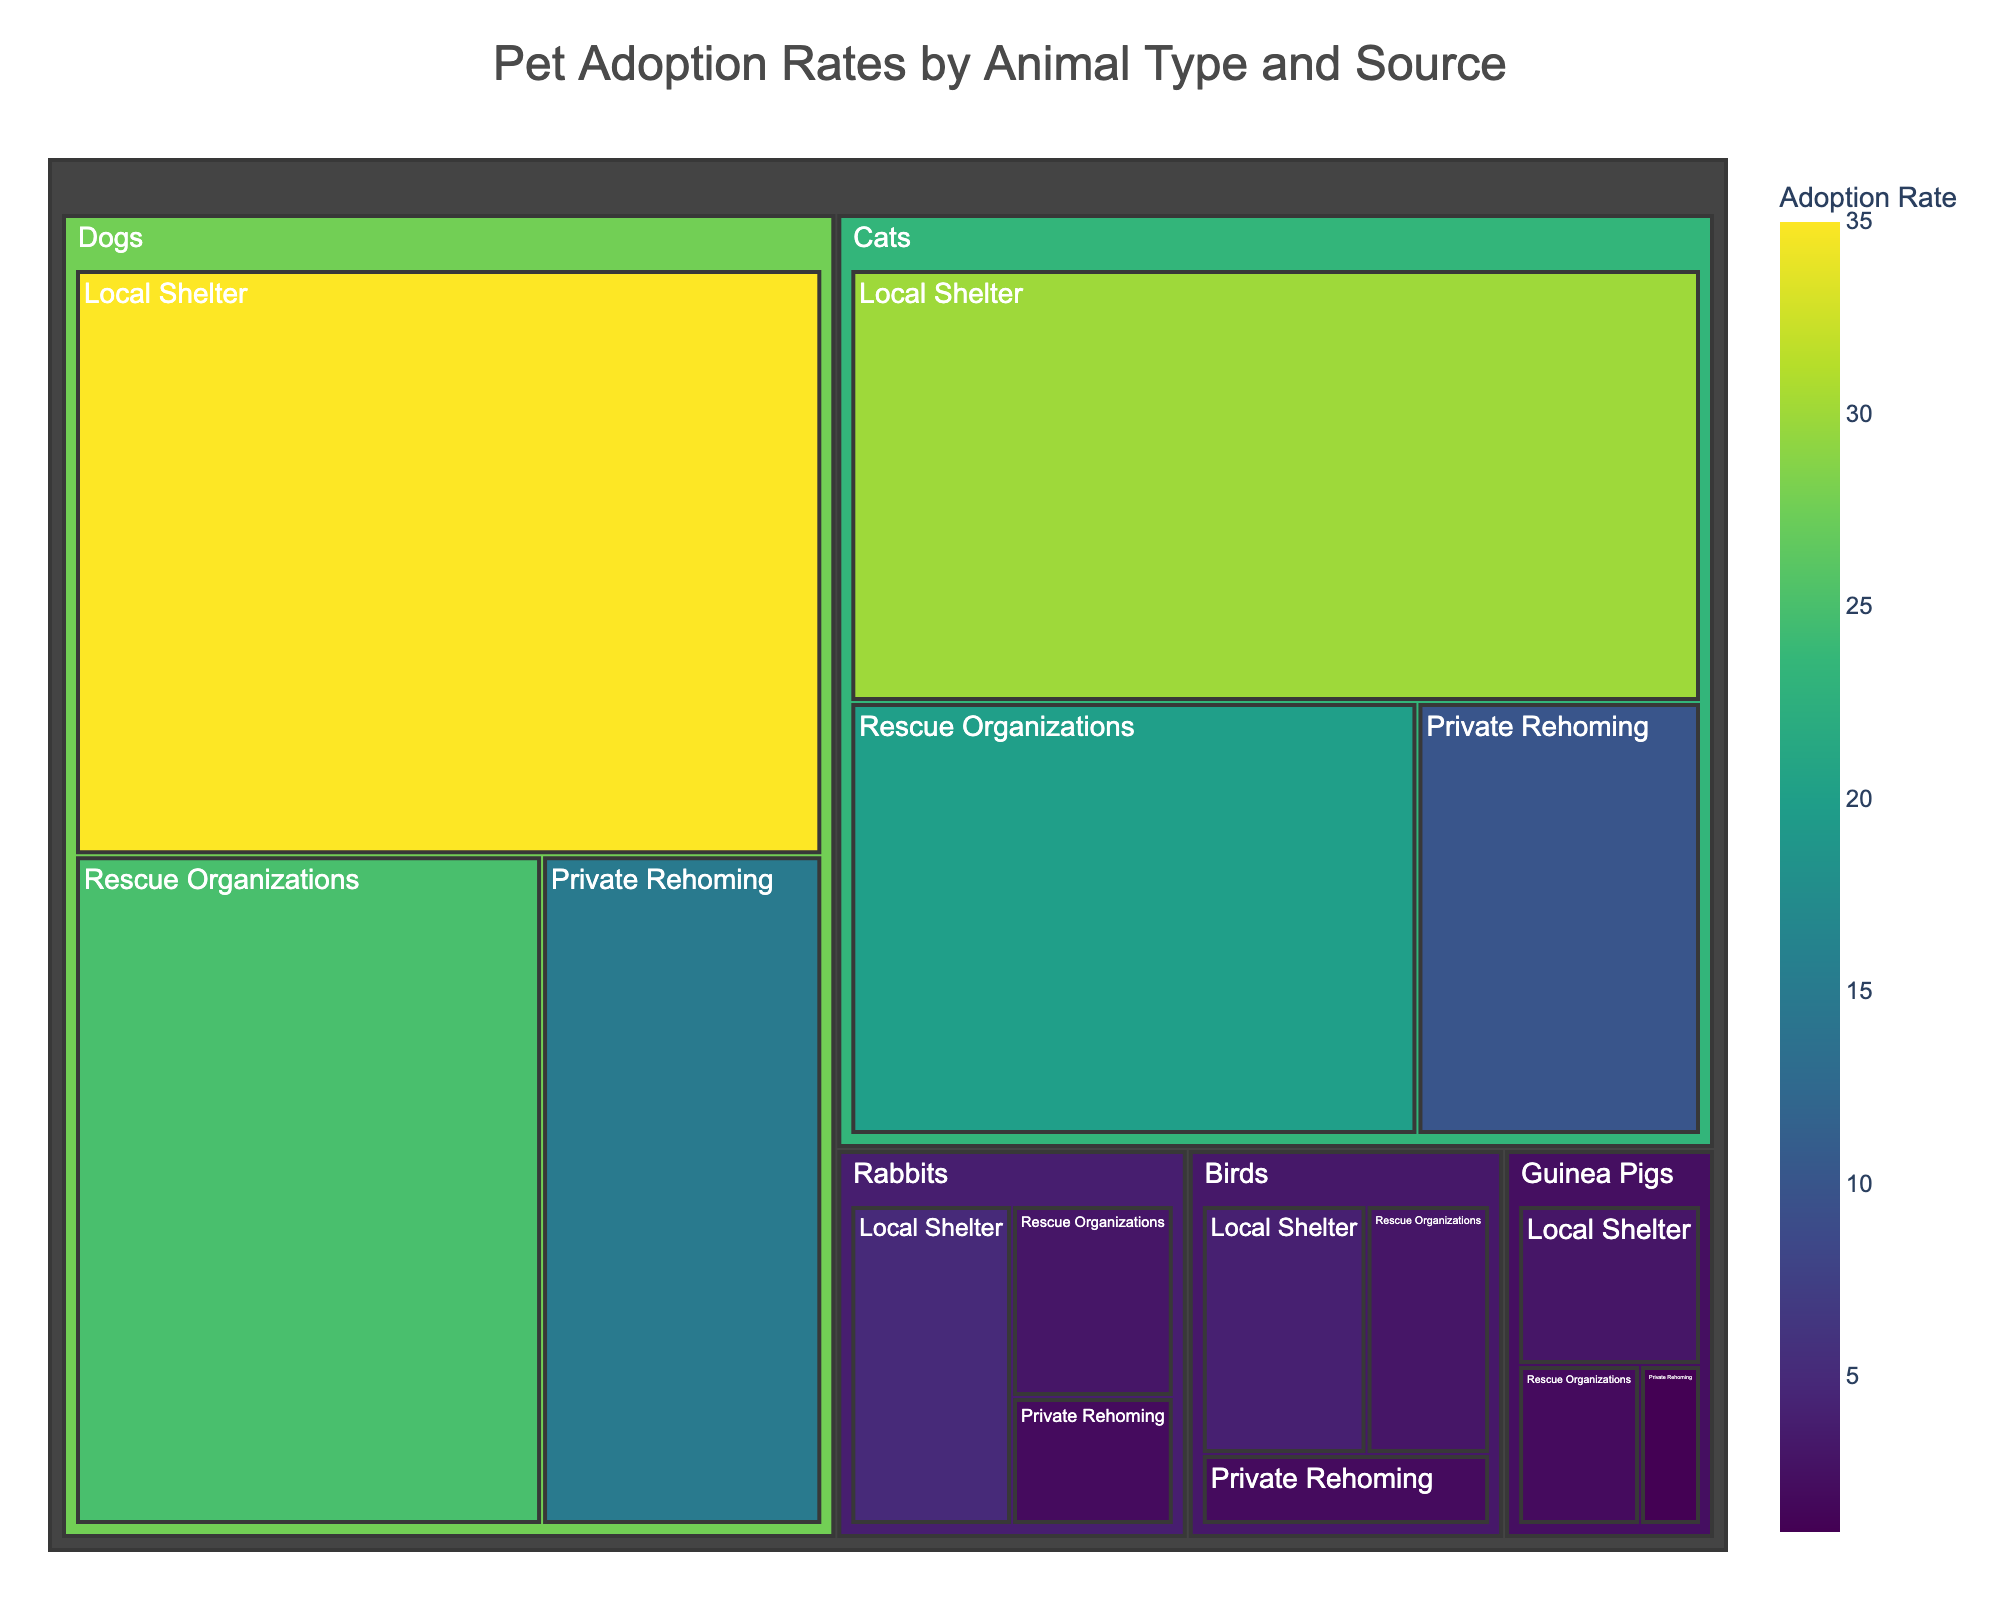What's the title of the treemap? The title of the treemap is typically displayed at the top of the figure.
Answer: Pet Adoption Rates by Animal Type and Source Which animal type has the highest adoption rate from Local Shelters? To find this, look for the largest segment under "Local Shelter" in terms of size and color intensity.
Answer: Dogs What is the adoption rate of Cats via Rescue Organizations? Locate the Cats section and then find the subdivision labeled "Rescue Organizations."
Answer: 20% Compare the adoption rates of Rabbits and Guinea Pigs from Private Rehoming. Which has a higher rate and by how much? Identify the adoption rates of Rabbits and Guinea Pigs under "Private Rehoming" and subtract one from the other. Rabbits have 2% and Guinea Pigs have 1%, so 2% - 1% = 1%.
Answer: Rabbits have a higher rate by 1% What is the combined adoption rate for Birds from all sources? Add the adoption rates of Birds from each source: Local Shelter (4%), Rescue Organizations (3%), and Private Rehoming (2%). 4% + 3% + 2% = 9%.
Answer: 9% Which animal type has the lowest overall adoption rate and what is it? Look for the animal type with the smallest combined segment size in the treemap. This is Guinea Pigs with rates from Local Shelter (3%), Rescue Organizations (2%), and Private Rehoming (1%), summing up to 6%.
Answer: Guinea Pigs, 6% How does the adoption rate of Dogs from Rescue Organizations compare to that of Cats from Local Shelters? Compare the adoption rates: Dogs via Rescue Organizations (25%) and Cats via Local Shelters (30%). 30% - 25% = 5%.
Answer: Cats from Local Shelters have a 5% higher adoption rate What is the average adoption rate for Cats across all sources? To compute the average, add the adoption rates of Cats from each source: Local Shelter (30%), Rescue Organizations (20%), and Private Rehoming (10%). Then divide by the number of sources, i.e., (30% + 20% + 10%) / 3 = 60% / 3.
Answer: 20% Which source has the highest overall adoption rate for all animal types? Sum the adoption rates for each source across all animal types and compare: Local Shelters (35%+30%+5%+3%+4% = 77%), Rescue Organizations (25%+20%+3%+2%+3% = 53%), and Private Rehoming (15%+10%+2%+1%+2% = 30%).
Answer: Local Shelters Which animal type has the lowest adoption rate from Rescue Organizations, and what is that rate? Locate the smallest segment under "Rescue Organizations." Guinea Pigs have the lowest at 2%.
Answer: Guinea Pigs, 2% 